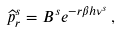<formula> <loc_0><loc_0><loc_500><loc_500>\widehat { p } _ { r } ^ { s } = B ^ { s } e ^ { - r \beta h \nu ^ { s } } \, ,</formula> 